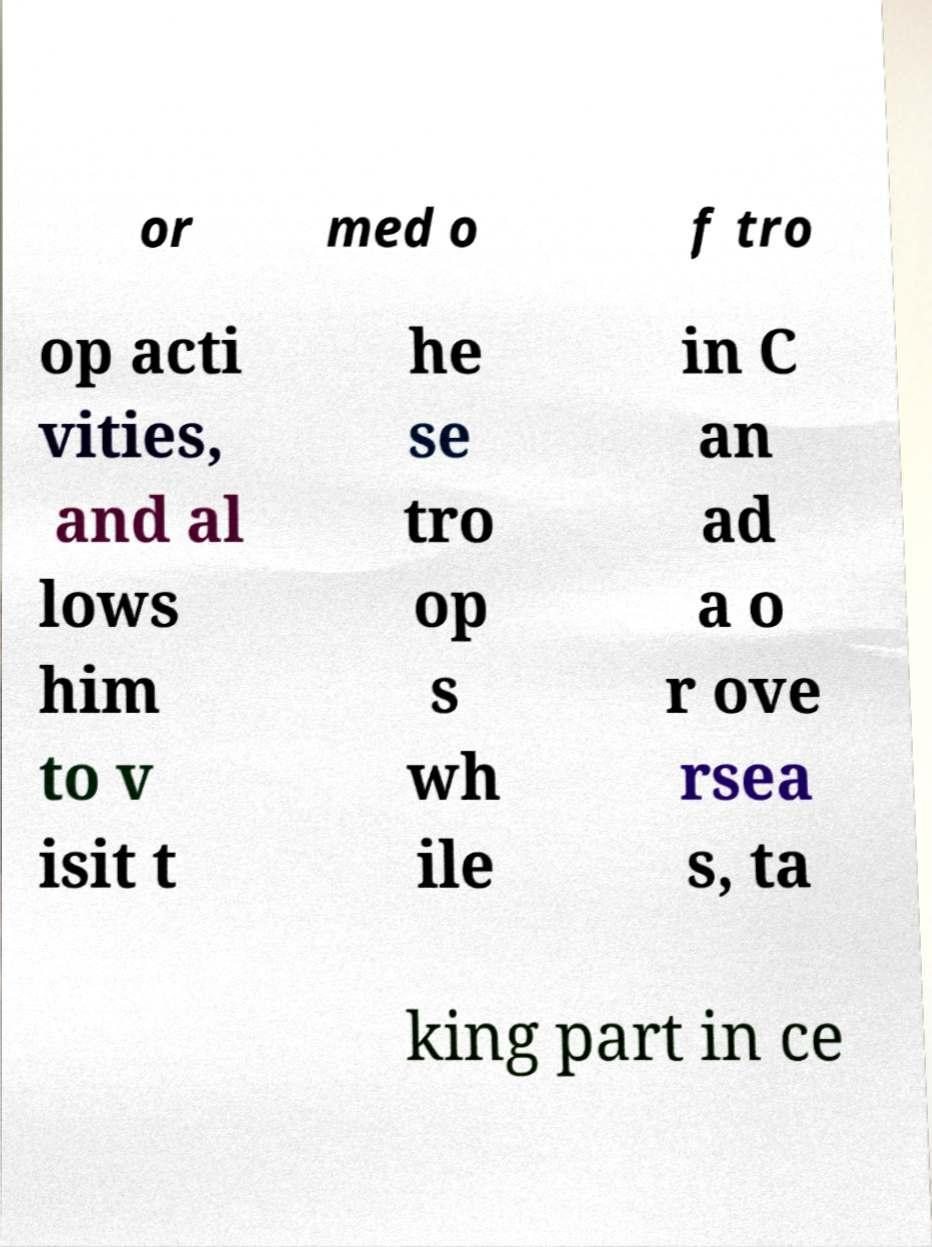For documentation purposes, I need the text within this image transcribed. Could you provide that? or med o f tro op acti vities, and al lows him to v isit t he se tro op s wh ile in C an ad a o r ove rsea s, ta king part in ce 